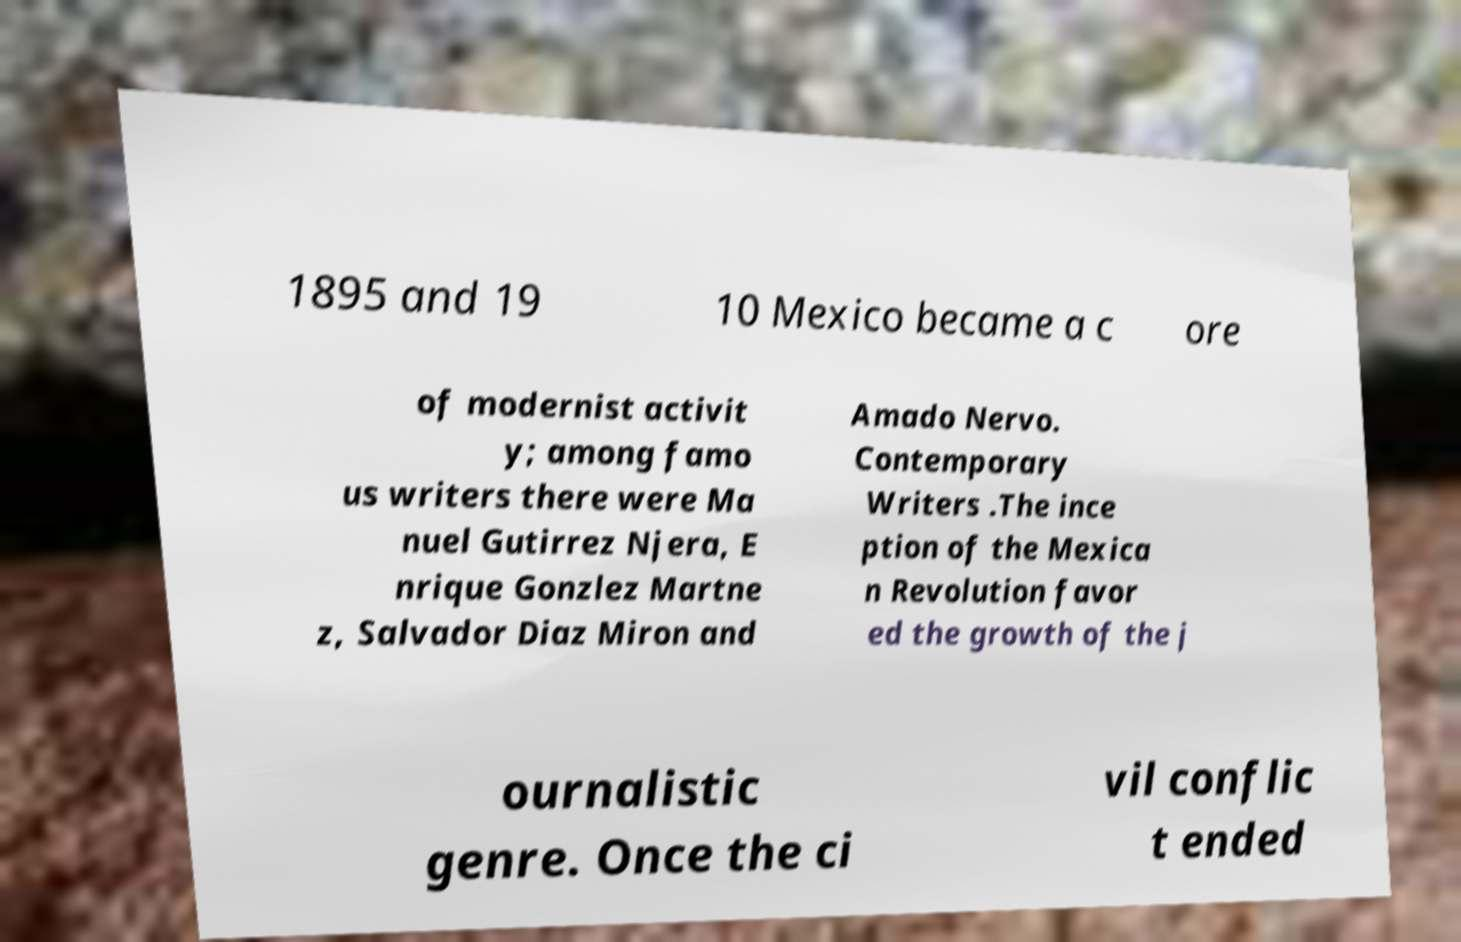Please read and relay the text visible in this image. What does it say? 1895 and 19 10 Mexico became a c ore of modernist activit y; among famo us writers there were Ma nuel Gutirrez Njera, E nrique Gonzlez Martne z, Salvador Diaz Miron and Amado Nervo. Contemporary Writers .The ince ption of the Mexica n Revolution favor ed the growth of the j ournalistic genre. Once the ci vil conflic t ended 